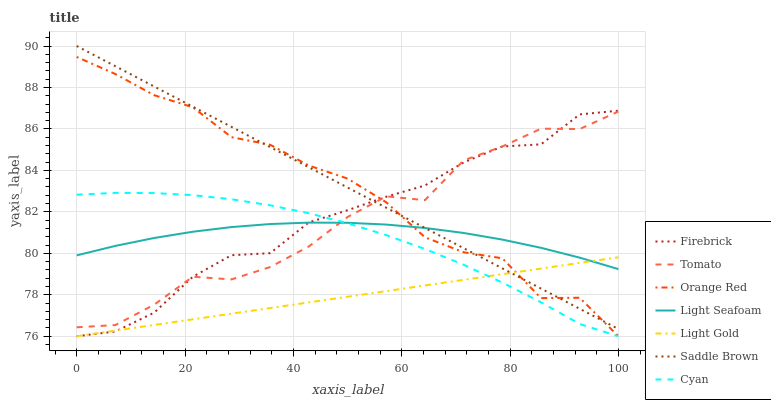Does Light Gold have the minimum area under the curve?
Answer yes or no. Yes. Does Saddle Brown have the maximum area under the curve?
Answer yes or no. Yes. Does Firebrick have the minimum area under the curve?
Answer yes or no. No. Does Firebrick have the maximum area under the curve?
Answer yes or no. No. Is Saddle Brown the smoothest?
Answer yes or no. Yes. Is Orange Red the roughest?
Answer yes or no. Yes. Is Firebrick the smoothest?
Answer yes or no. No. Is Firebrick the roughest?
Answer yes or no. No. Does Saddle Brown have the lowest value?
Answer yes or no. No. Does Saddle Brown have the highest value?
Answer yes or no. Yes. Does Firebrick have the highest value?
Answer yes or no. No. Is Light Gold less than Tomato?
Answer yes or no. Yes. Is Saddle Brown greater than Cyan?
Answer yes or no. Yes. Does Firebrick intersect Light Gold?
Answer yes or no. Yes. Is Firebrick less than Light Gold?
Answer yes or no. No. Is Firebrick greater than Light Gold?
Answer yes or no. No. Does Light Gold intersect Tomato?
Answer yes or no. No. 